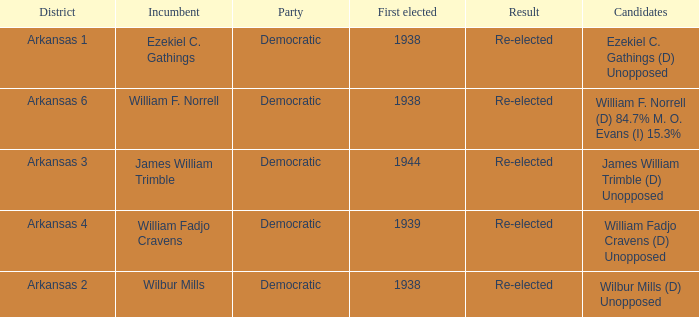How many districts had William F. Norrell as the incumbent? 1.0. 